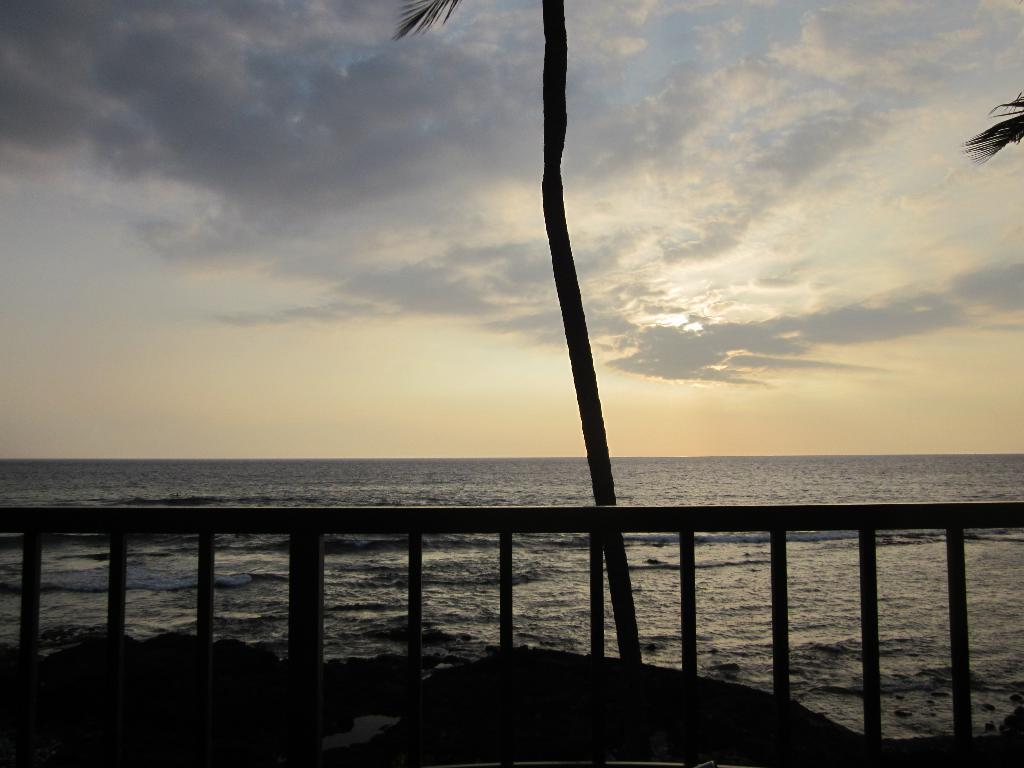What is the color scheme of the image? The image is black and white. What structure can be seen in the middle of the image? There is a wooden bridge in the middle of the image. What is visible behind the bridge? There is water visible behind the bridge. What type of vegetation is in the middle of the image? There is a tall tree in the middle of the image. What is visible at the top of the image? The sky is visible at the top of the image. Where is the pencil used for drawing the bridge in the image? There is no pencil or drawing present in the image; it is a photograph of a real wooden bridge. What type of key can be seen opening the tall tree in the image? There is no key or locked tree present in the image; it is a photograph of a real tall tree. 